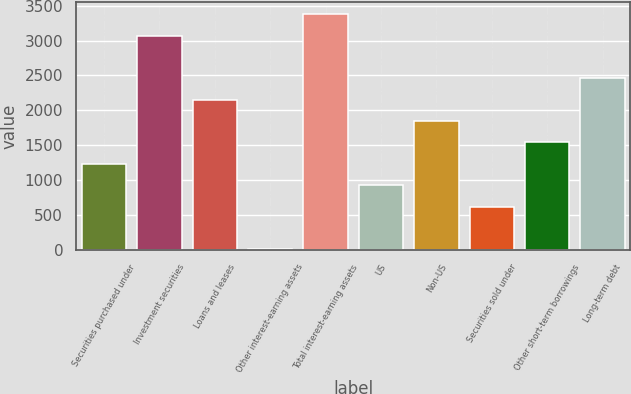<chart> <loc_0><loc_0><loc_500><loc_500><bar_chart><fcel>Securities purchased under<fcel>Investment securities<fcel>Loans and leases<fcel>Other interest-earning assets<fcel>Total interest-earning assets<fcel>US<fcel>Non-US<fcel>Securities sold under<fcel>Other short-term borrowings<fcel>Long-term debt<nl><fcel>1230.8<fcel>3074<fcel>2152.4<fcel>2<fcel>3381.2<fcel>923.6<fcel>1845.2<fcel>616.4<fcel>1538<fcel>2459.6<nl></chart> 